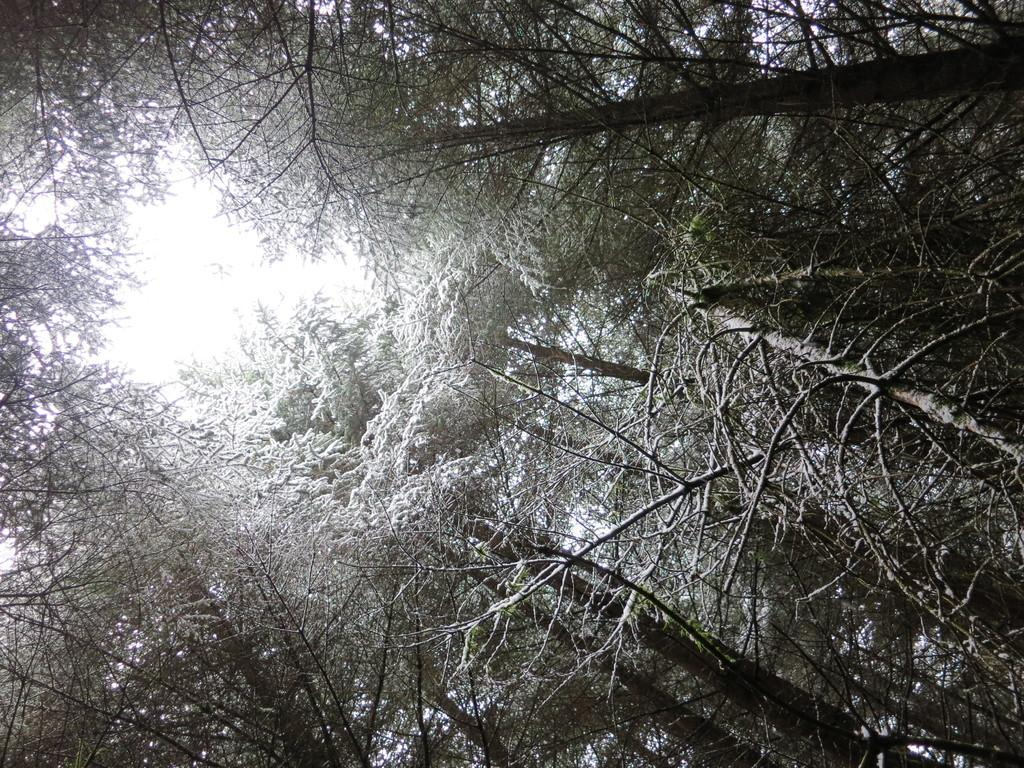What type of vegetation can be seen in the image? There are trees in the image. What color is the background of the image? The background of the image is white. What type of secretary is working in the image? There is no secretary present in the image; it features trees and a white background. What nation is depicted in the image? The image does not depict any specific nation; it simply shows trees and a white background. 